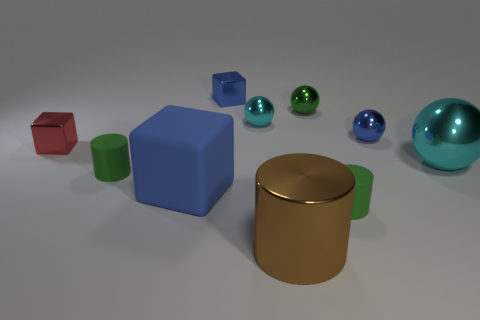What is the color of the other big object that is the same shape as the red metal object?
Keep it short and to the point. Blue. There is a cyan thing behind the blue sphere; how many tiny green rubber cylinders are to the left of it?
Provide a short and direct response. 1. How many spheres are either yellow objects or large cyan things?
Give a very brief answer. 1. Are any tiny green matte cylinders visible?
Keep it short and to the point. Yes. What size is the other matte thing that is the same shape as the small red thing?
Your answer should be very brief. Large. What is the shape of the large cyan metallic thing to the right of the tiny shiny sphere on the left side of the large brown metal object?
Your answer should be very brief. Sphere. What number of purple objects are either small cylinders or big cylinders?
Keep it short and to the point. 0. The large matte object is what color?
Provide a succinct answer. Blue. Do the brown shiny thing and the matte block have the same size?
Provide a succinct answer. Yes. Is the material of the large brown cylinder the same as the tiny green object that is left of the large brown object?
Your answer should be very brief. No. 